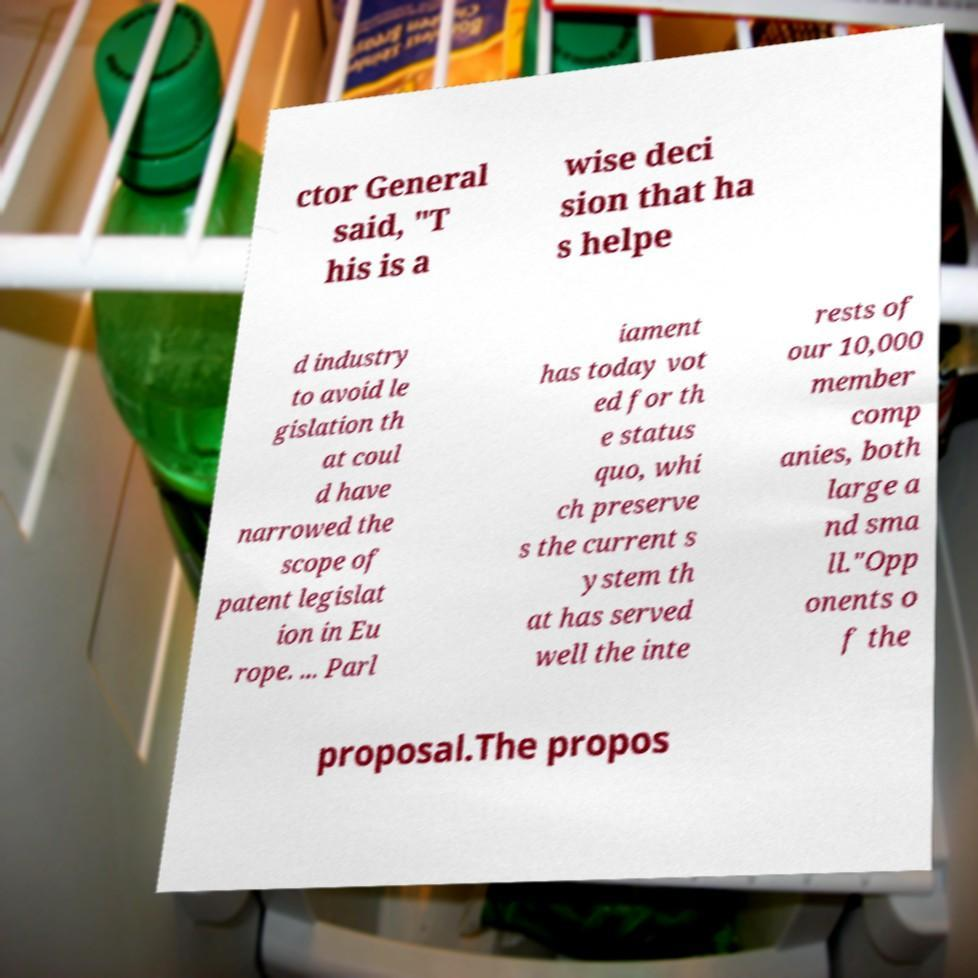Could you assist in decoding the text presented in this image and type it out clearly? ctor General said, "T his is a wise deci sion that ha s helpe d industry to avoid le gislation th at coul d have narrowed the scope of patent legislat ion in Eu rope. ... Parl iament has today vot ed for th e status quo, whi ch preserve s the current s ystem th at has served well the inte rests of our 10,000 member comp anies, both large a nd sma ll."Opp onents o f the proposal.The propos 